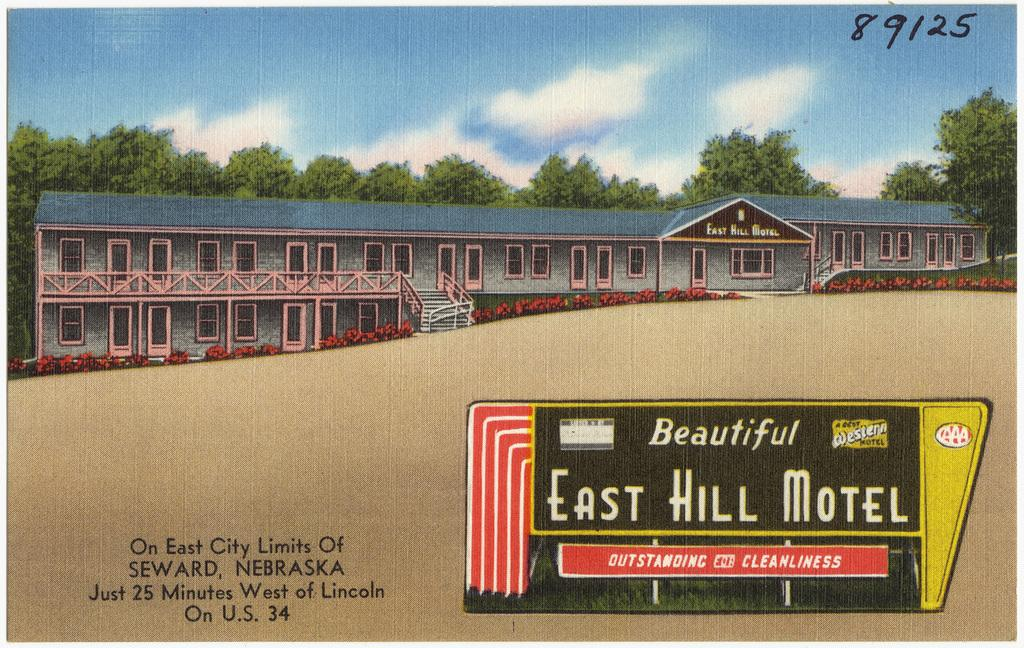<image>
Give a short and clear explanation of the subsequent image. a small poster that says 'beautiful east hill motel' on it 